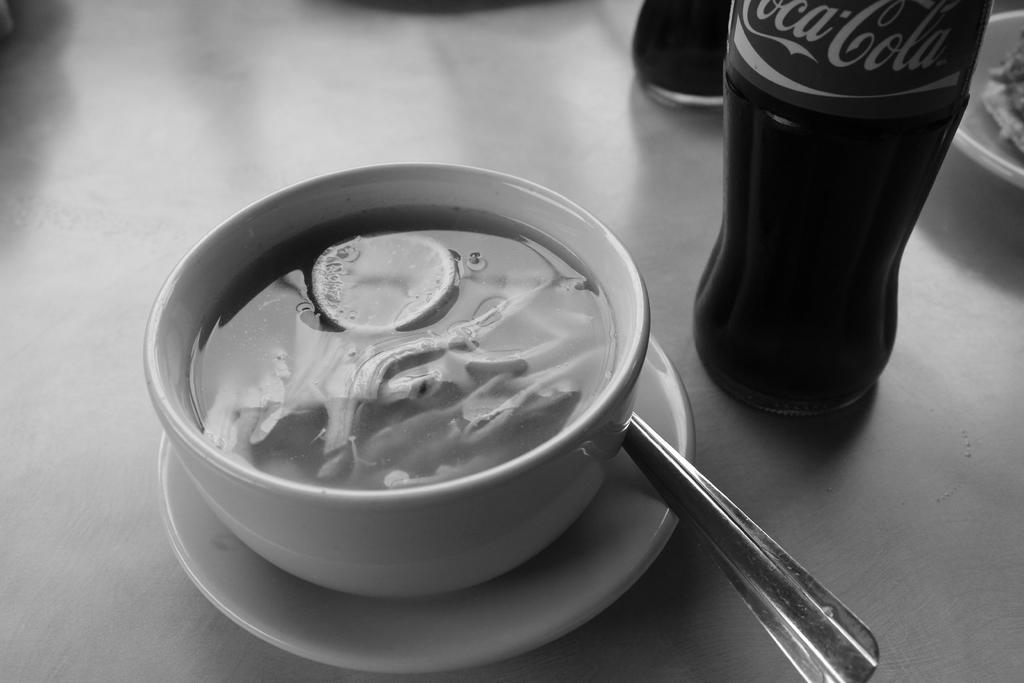<image>
Offer a succinct explanation of the picture presented. a glass bottle with a coca cola label on it in front of a bowl of soup 